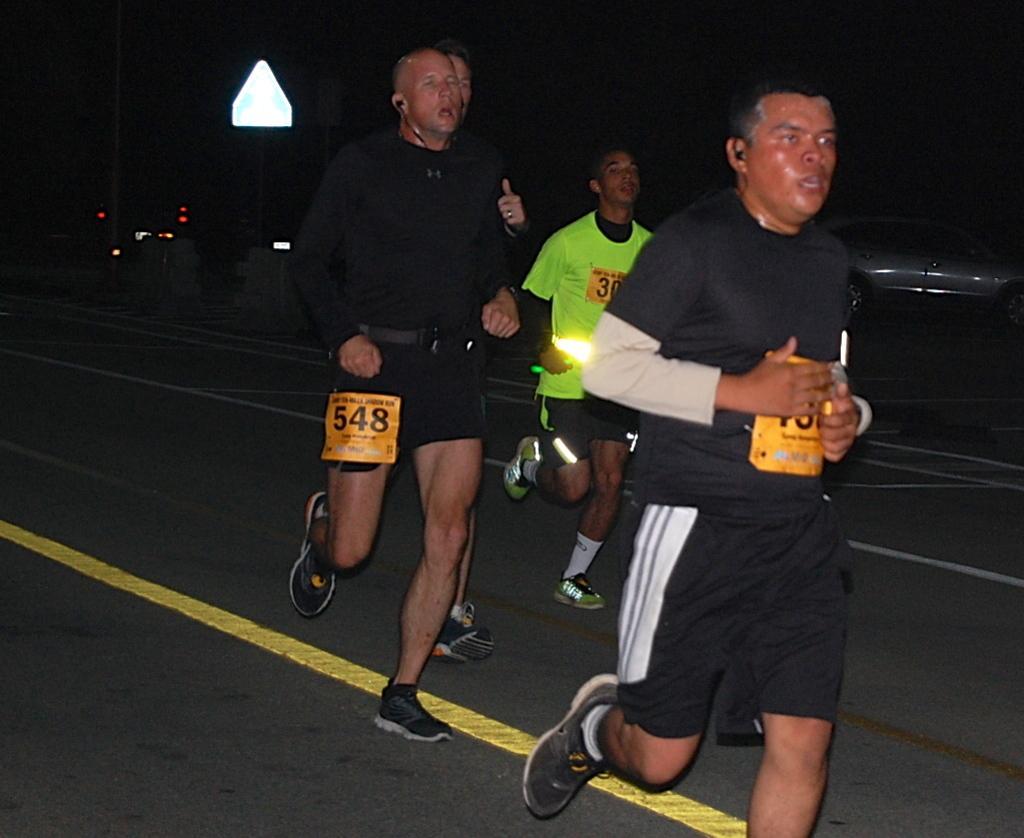In one or two sentences, can you explain what this image depicts? In this picture we can observe four members running on the road. We can observe two men were wearing black color T shirts and the other man was wearing green color T shirt. We can observe a white color board on the left side. In the background it is completely dark. There is a car on the right side. 